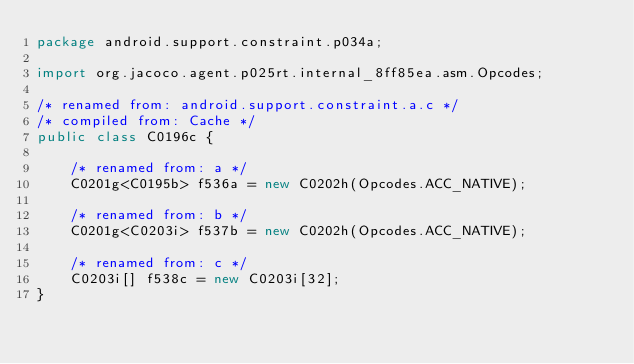<code> <loc_0><loc_0><loc_500><loc_500><_Java_>package android.support.constraint.p034a;

import org.jacoco.agent.p025rt.internal_8ff85ea.asm.Opcodes;

/* renamed from: android.support.constraint.a.c */
/* compiled from: Cache */
public class C0196c {

    /* renamed from: a */
    C0201g<C0195b> f536a = new C0202h(Opcodes.ACC_NATIVE);

    /* renamed from: b */
    C0201g<C0203i> f537b = new C0202h(Opcodes.ACC_NATIVE);

    /* renamed from: c */
    C0203i[] f538c = new C0203i[32];
}
</code> 